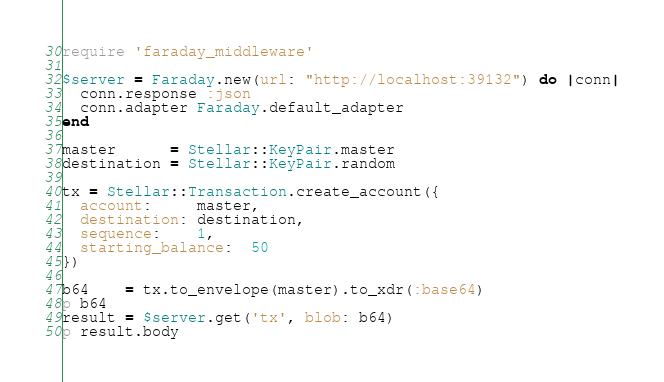Convert code to text. <code><loc_0><loc_0><loc_500><loc_500><_Ruby_>require 'faraday_middleware'

$server = Faraday.new(url: "http://localhost:39132") do |conn|
  conn.response :json
  conn.adapter Faraday.default_adapter
end

master      = Stellar::KeyPair.master
destination = Stellar::KeyPair.random

tx = Stellar::Transaction.create_account({
  account:     master,
  destination: destination,
  sequence:    1,
  starting_balance:  50
})

b64    = tx.to_envelope(master).to_xdr(:base64)
p b64
result = $server.get('tx', blob: b64)
p result.body
</code> 